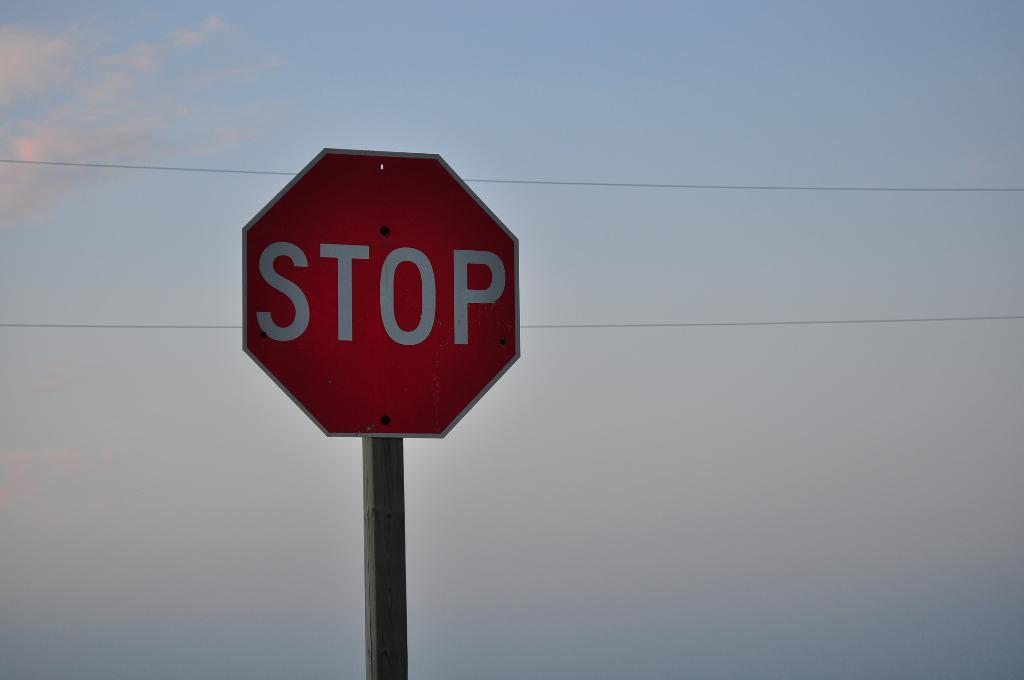<image>
Relay a brief, clear account of the picture shown. A stop sign against a beautiful blue sky. 